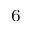Convert formula to latex. <formula><loc_0><loc_0><loc_500><loc_500>^ { 6 }</formula> 